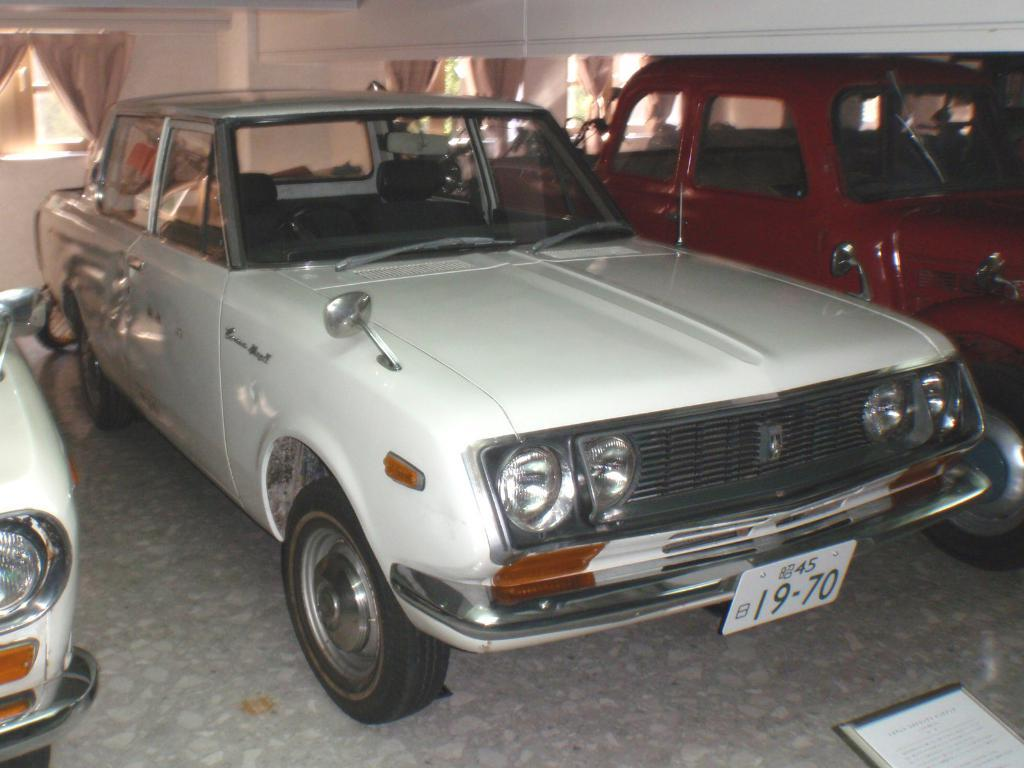What is located in the middle of the image? There are cars in the middle of the image. What can be seen in the background of the image? There is a wall in the background of the image. Can you describe the object in the bottom right corner of the image? Unfortunately, the provided facts do not give enough information to describe the object in the bottom right corner of the image. What type of badge is the person wearing on their vacation in the image? There is no person or vacation present in the image, and therefore no badge can be observed. What type of food is being served at the event in the image? There is no event or food present in the image. 